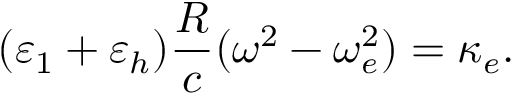<formula> <loc_0><loc_0><loc_500><loc_500>( \varepsilon _ { 1 } + \varepsilon _ { h } ) \frac { R } { c } ( \omega ^ { 2 } - \omega _ { e } ^ { 2 } ) = \kappa _ { e } .</formula> 